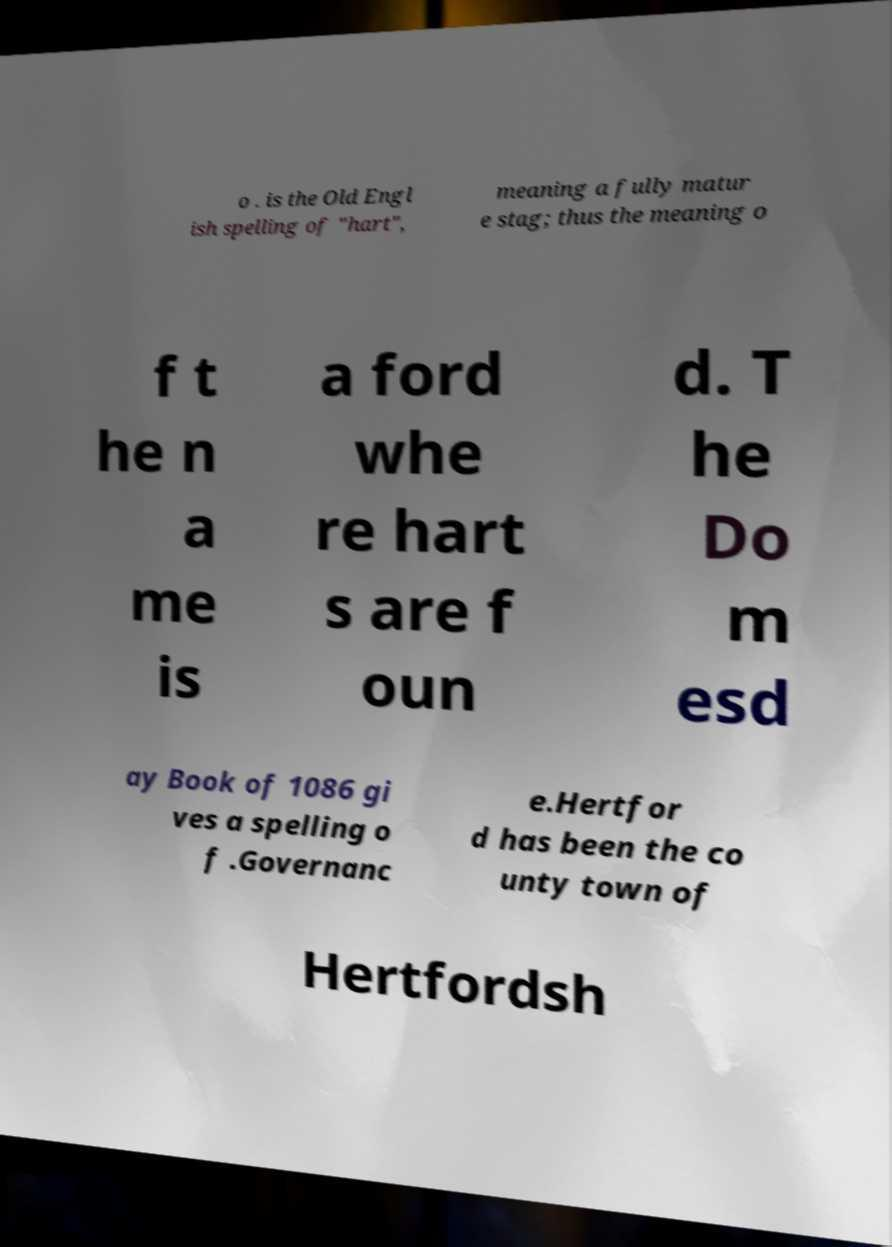Can you accurately transcribe the text from the provided image for me? o . is the Old Engl ish spelling of "hart", meaning a fully matur e stag; thus the meaning o f t he n a me is a ford whe re hart s are f oun d. T he Do m esd ay Book of 1086 gi ves a spelling o f .Governanc e.Hertfor d has been the co unty town of Hertfordsh 